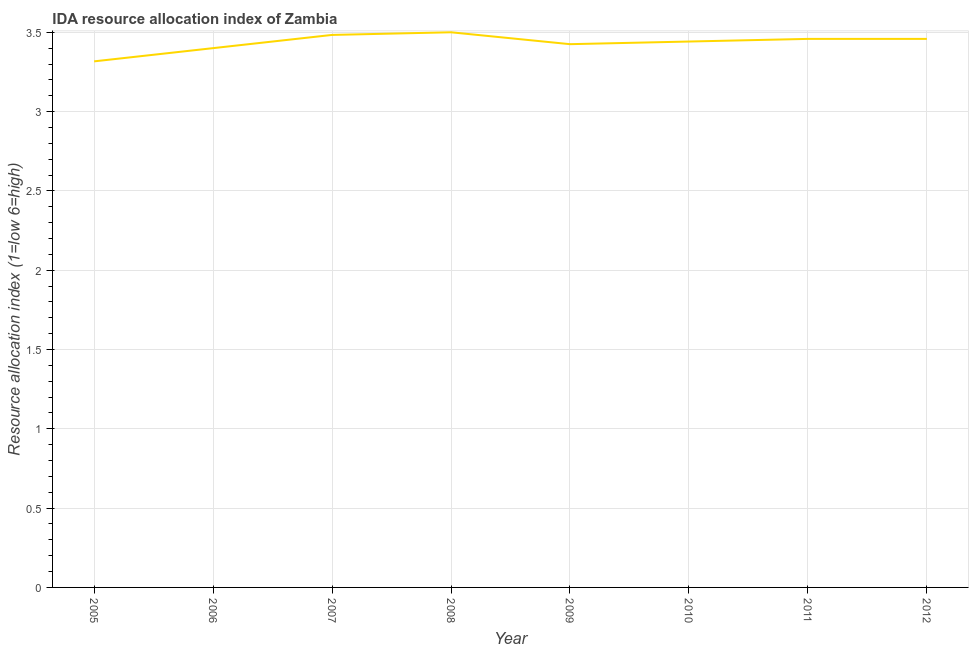What is the ida resource allocation index in 2007?
Your response must be concise. 3.48. Across all years, what is the maximum ida resource allocation index?
Make the answer very short. 3.5. Across all years, what is the minimum ida resource allocation index?
Your response must be concise. 3.32. In which year was the ida resource allocation index maximum?
Make the answer very short. 2008. In which year was the ida resource allocation index minimum?
Keep it short and to the point. 2005. What is the sum of the ida resource allocation index?
Your response must be concise. 27.48. What is the difference between the ida resource allocation index in 2005 and 2008?
Provide a short and direct response. -0.18. What is the average ida resource allocation index per year?
Provide a succinct answer. 3.44. What is the median ida resource allocation index?
Provide a succinct answer. 3.45. Do a majority of the years between 2009 and 2010 (inclusive) have ida resource allocation index greater than 1.9 ?
Your answer should be very brief. Yes. What is the ratio of the ida resource allocation index in 2007 to that in 2011?
Offer a very short reply. 1.01. Is the ida resource allocation index in 2008 less than that in 2011?
Your answer should be compact. No. What is the difference between the highest and the second highest ida resource allocation index?
Keep it short and to the point. 0.02. What is the difference between the highest and the lowest ida resource allocation index?
Make the answer very short. 0.18. In how many years, is the ida resource allocation index greater than the average ida resource allocation index taken over all years?
Keep it short and to the point. 5. How many years are there in the graph?
Provide a short and direct response. 8. What is the difference between two consecutive major ticks on the Y-axis?
Keep it short and to the point. 0.5. Are the values on the major ticks of Y-axis written in scientific E-notation?
Provide a succinct answer. No. What is the title of the graph?
Your response must be concise. IDA resource allocation index of Zambia. What is the label or title of the Y-axis?
Your answer should be very brief. Resource allocation index (1=low 6=high). What is the Resource allocation index (1=low 6=high) in 2005?
Provide a succinct answer. 3.32. What is the Resource allocation index (1=low 6=high) of 2007?
Keep it short and to the point. 3.48. What is the Resource allocation index (1=low 6=high) in 2008?
Keep it short and to the point. 3.5. What is the Resource allocation index (1=low 6=high) of 2009?
Offer a terse response. 3.42. What is the Resource allocation index (1=low 6=high) of 2010?
Give a very brief answer. 3.44. What is the Resource allocation index (1=low 6=high) in 2011?
Offer a very short reply. 3.46. What is the Resource allocation index (1=low 6=high) in 2012?
Offer a terse response. 3.46. What is the difference between the Resource allocation index (1=low 6=high) in 2005 and 2006?
Your answer should be compact. -0.08. What is the difference between the Resource allocation index (1=low 6=high) in 2005 and 2007?
Provide a succinct answer. -0.17. What is the difference between the Resource allocation index (1=low 6=high) in 2005 and 2008?
Provide a succinct answer. -0.18. What is the difference between the Resource allocation index (1=low 6=high) in 2005 and 2009?
Provide a short and direct response. -0.11. What is the difference between the Resource allocation index (1=low 6=high) in 2005 and 2010?
Your response must be concise. -0.12. What is the difference between the Resource allocation index (1=low 6=high) in 2005 and 2011?
Provide a succinct answer. -0.14. What is the difference between the Resource allocation index (1=low 6=high) in 2005 and 2012?
Provide a short and direct response. -0.14. What is the difference between the Resource allocation index (1=low 6=high) in 2006 and 2007?
Keep it short and to the point. -0.08. What is the difference between the Resource allocation index (1=low 6=high) in 2006 and 2009?
Ensure brevity in your answer.  -0.03. What is the difference between the Resource allocation index (1=low 6=high) in 2006 and 2010?
Your answer should be compact. -0.04. What is the difference between the Resource allocation index (1=low 6=high) in 2006 and 2011?
Your response must be concise. -0.06. What is the difference between the Resource allocation index (1=low 6=high) in 2006 and 2012?
Your response must be concise. -0.06. What is the difference between the Resource allocation index (1=low 6=high) in 2007 and 2008?
Provide a short and direct response. -0.02. What is the difference between the Resource allocation index (1=low 6=high) in 2007 and 2009?
Offer a terse response. 0.06. What is the difference between the Resource allocation index (1=low 6=high) in 2007 and 2010?
Give a very brief answer. 0.04. What is the difference between the Resource allocation index (1=low 6=high) in 2007 and 2011?
Provide a succinct answer. 0.03. What is the difference between the Resource allocation index (1=low 6=high) in 2007 and 2012?
Make the answer very short. 0.03. What is the difference between the Resource allocation index (1=low 6=high) in 2008 and 2009?
Give a very brief answer. 0.07. What is the difference between the Resource allocation index (1=low 6=high) in 2008 and 2010?
Offer a very short reply. 0.06. What is the difference between the Resource allocation index (1=low 6=high) in 2008 and 2011?
Ensure brevity in your answer.  0.04. What is the difference between the Resource allocation index (1=low 6=high) in 2008 and 2012?
Provide a succinct answer. 0.04. What is the difference between the Resource allocation index (1=low 6=high) in 2009 and 2010?
Your answer should be compact. -0.02. What is the difference between the Resource allocation index (1=low 6=high) in 2009 and 2011?
Give a very brief answer. -0.03. What is the difference between the Resource allocation index (1=low 6=high) in 2009 and 2012?
Provide a short and direct response. -0.03. What is the difference between the Resource allocation index (1=low 6=high) in 2010 and 2011?
Provide a succinct answer. -0.02. What is the difference between the Resource allocation index (1=low 6=high) in 2010 and 2012?
Ensure brevity in your answer.  -0.02. What is the ratio of the Resource allocation index (1=low 6=high) in 2005 to that in 2006?
Provide a succinct answer. 0.97. What is the ratio of the Resource allocation index (1=low 6=high) in 2005 to that in 2007?
Offer a terse response. 0.95. What is the ratio of the Resource allocation index (1=low 6=high) in 2005 to that in 2008?
Give a very brief answer. 0.95. What is the ratio of the Resource allocation index (1=low 6=high) in 2005 to that in 2009?
Make the answer very short. 0.97. What is the ratio of the Resource allocation index (1=low 6=high) in 2005 to that in 2010?
Provide a succinct answer. 0.96. What is the ratio of the Resource allocation index (1=low 6=high) in 2005 to that in 2011?
Ensure brevity in your answer.  0.96. What is the ratio of the Resource allocation index (1=low 6=high) in 2006 to that in 2007?
Keep it short and to the point. 0.98. What is the ratio of the Resource allocation index (1=low 6=high) in 2006 to that in 2009?
Your answer should be compact. 0.99. What is the ratio of the Resource allocation index (1=low 6=high) in 2006 to that in 2010?
Make the answer very short. 0.99. What is the ratio of the Resource allocation index (1=low 6=high) in 2006 to that in 2011?
Provide a succinct answer. 0.98. What is the ratio of the Resource allocation index (1=low 6=high) in 2006 to that in 2012?
Provide a succinct answer. 0.98. What is the ratio of the Resource allocation index (1=low 6=high) in 2007 to that in 2008?
Your answer should be compact. 0.99. What is the ratio of the Resource allocation index (1=low 6=high) in 2007 to that in 2009?
Make the answer very short. 1.02. What is the ratio of the Resource allocation index (1=low 6=high) in 2007 to that in 2010?
Keep it short and to the point. 1.01. What is the ratio of the Resource allocation index (1=low 6=high) in 2007 to that in 2011?
Your answer should be very brief. 1.01. What is the ratio of the Resource allocation index (1=low 6=high) in 2007 to that in 2012?
Your answer should be compact. 1.01. What is the ratio of the Resource allocation index (1=low 6=high) in 2008 to that in 2010?
Give a very brief answer. 1.02. What is the ratio of the Resource allocation index (1=low 6=high) in 2008 to that in 2011?
Provide a short and direct response. 1.01. What is the ratio of the Resource allocation index (1=low 6=high) in 2008 to that in 2012?
Your answer should be compact. 1.01. What is the ratio of the Resource allocation index (1=low 6=high) in 2009 to that in 2010?
Offer a very short reply. 0.99. What is the ratio of the Resource allocation index (1=low 6=high) in 2009 to that in 2011?
Offer a very short reply. 0.99. What is the ratio of the Resource allocation index (1=low 6=high) in 2010 to that in 2011?
Keep it short and to the point. 0.99. 